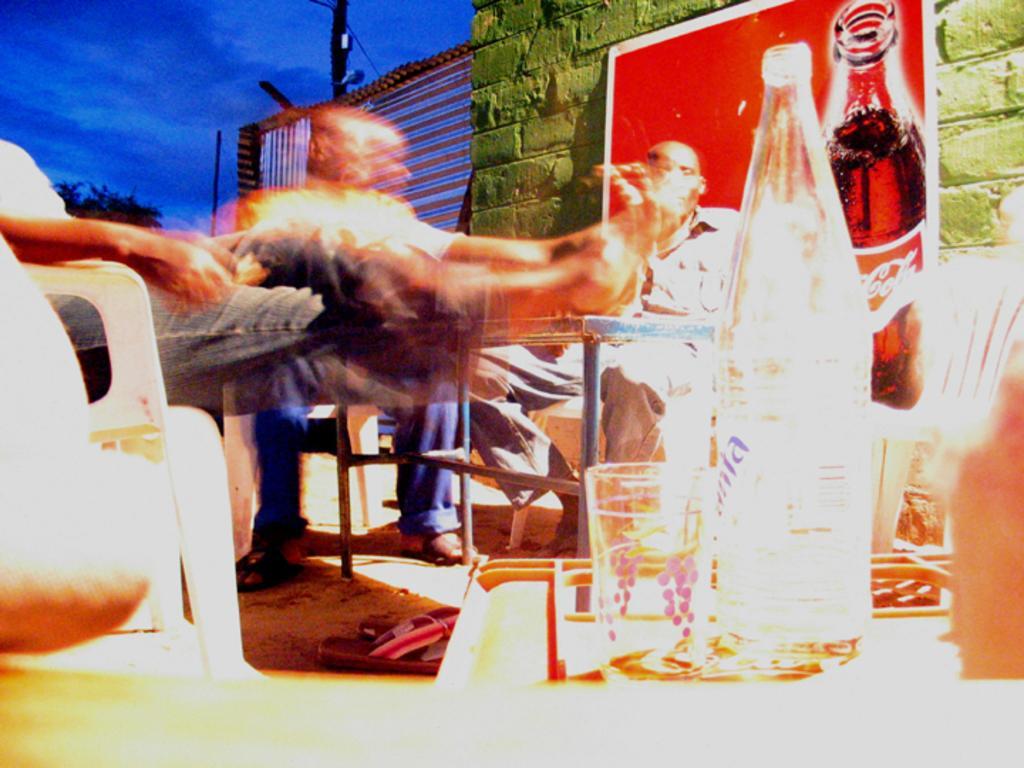Describe this image in one or two sentences. There are two people who are sitting on a chair. Here we can see a cool drink bottle. In the background we can see a sky. 